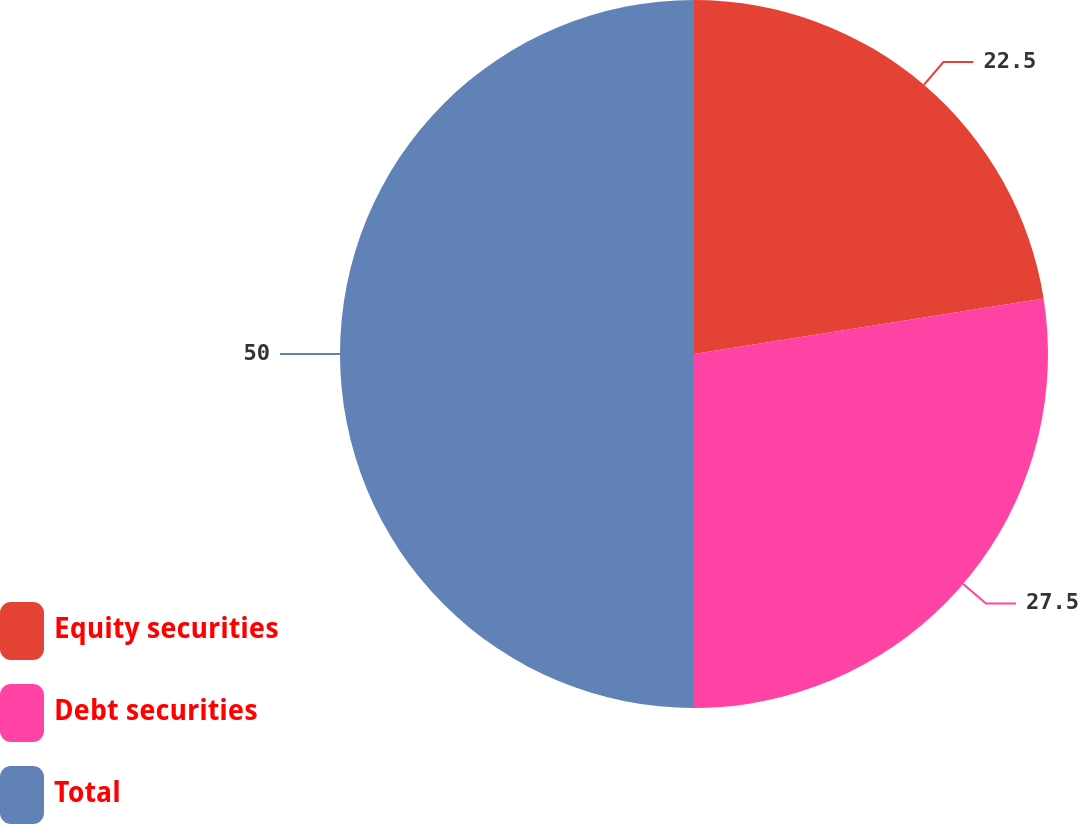<chart> <loc_0><loc_0><loc_500><loc_500><pie_chart><fcel>Equity securities<fcel>Debt securities<fcel>Total<nl><fcel>22.5%<fcel>27.5%<fcel>50.0%<nl></chart> 